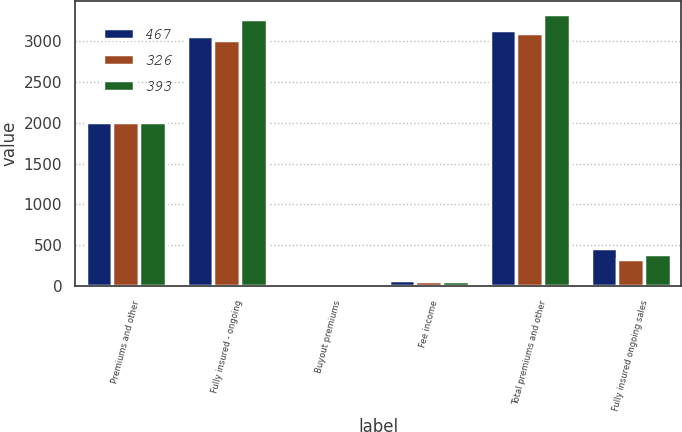<chart> <loc_0><loc_0><loc_500><loc_500><stacked_bar_chart><ecel><fcel>Premiums and other<fcel>Fully insured - ongoing<fcel>Buyout premiums<fcel>Fee income<fcel>Total premiums and other<fcel>Fully insured ongoing sales<nl><fcel>467<fcel>2015<fcel>3068<fcel>1<fcel>67<fcel>3136<fcel>467<nl><fcel>326<fcel>2014<fcel>3014<fcel>20<fcel>61<fcel>3095<fcel>326<nl><fcel>393<fcel>2013<fcel>3272<fcel>1<fcel>57<fcel>3330<fcel>393<nl></chart> 